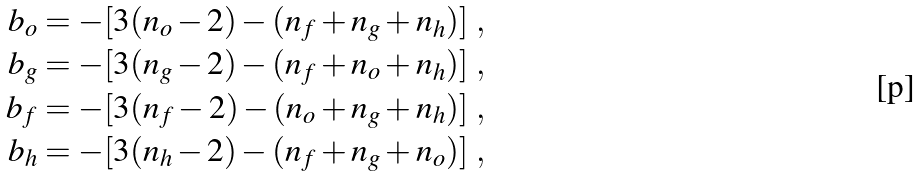<formula> <loc_0><loc_0><loc_500><loc_500>b _ { o } & = - [ 3 ( n _ { o } - 2 ) - ( n _ { f } + n _ { g } + n _ { h } ) ] \ , \\ b _ { g } & = - [ 3 ( n _ { g } - 2 ) - ( n _ { f } + n _ { o } + n _ { h } ) ] \ , \\ b _ { f } & = - [ 3 ( n _ { f } - 2 ) - ( n _ { o } + n _ { g } + n _ { h } ) ] \ , \\ b _ { h } & = - [ 3 ( n _ { h } - 2 ) - ( n _ { f } + n _ { g } + n _ { o } ) ] \ ,</formula> 